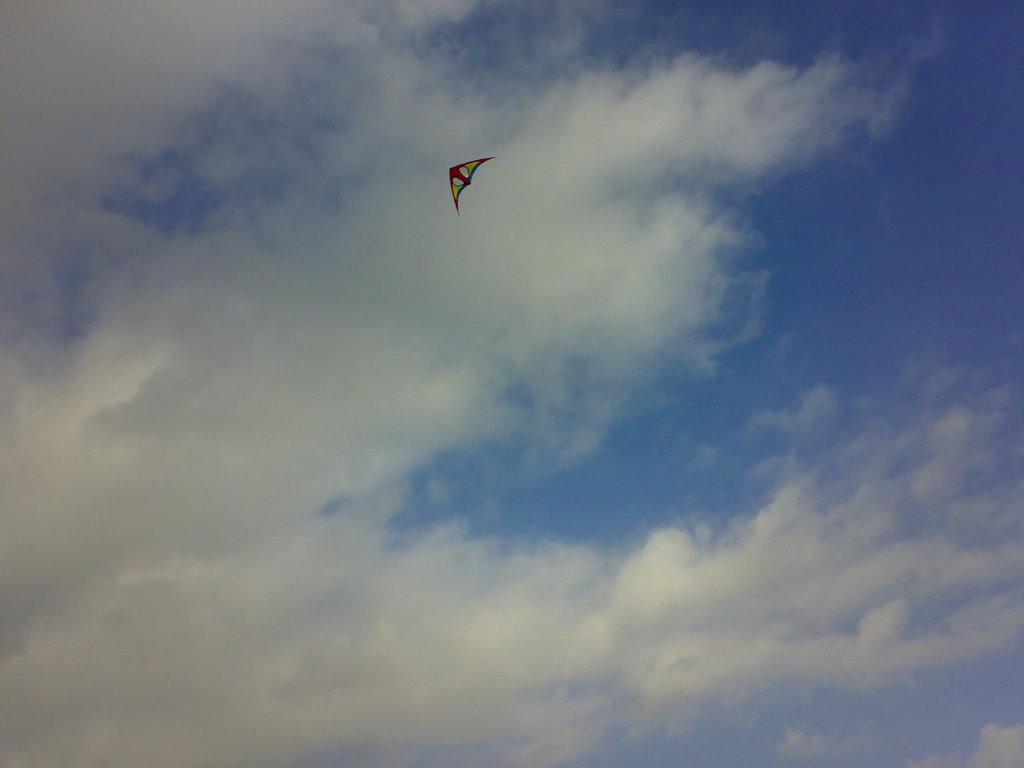What object is the main focus of the image? There is a kite in the image. What can be seen in the background of the image? There is sky visible in the background of the image. What is the condition of the sky in the image? Clouds are present in the sky. What type of steam can be seen coming from the kite in the image? There is no steam present in the image; it features a kite and clouds in the sky. How many spiders are visible on the kite in the image? There are no spiders present on the kite in the image. 